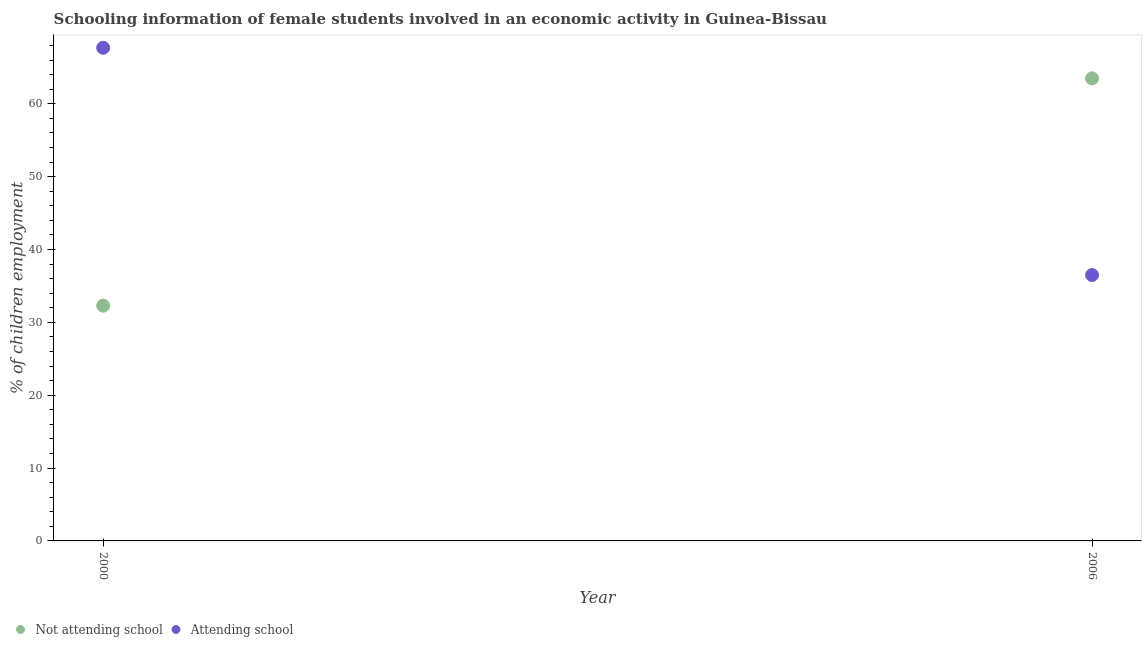What is the percentage of employed females who are not attending school in 2000?
Your answer should be very brief. 32.3. Across all years, what is the maximum percentage of employed females who are not attending school?
Your response must be concise. 63.5. Across all years, what is the minimum percentage of employed females who are attending school?
Offer a terse response. 36.5. In which year was the percentage of employed females who are not attending school minimum?
Keep it short and to the point. 2000. What is the total percentage of employed females who are attending school in the graph?
Make the answer very short. 104.2. What is the difference between the percentage of employed females who are not attending school in 2000 and that in 2006?
Make the answer very short. -31.2. What is the difference between the percentage of employed females who are attending school in 2006 and the percentage of employed females who are not attending school in 2000?
Keep it short and to the point. 4.2. What is the average percentage of employed females who are attending school per year?
Give a very brief answer. 52.1. In the year 2006, what is the difference between the percentage of employed females who are not attending school and percentage of employed females who are attending school?
Provide a short and direct response. 27. What is the ratio of the percentage of employed females who are attending school in 2000 to that in 2006?
Provide a short and direct response. 1.85. Is the percentage of employed females who are not attending school in 2000 less than that in 2006?
Your answer should be very brief. Yes. In how many years, is the percentage of employed females who are not attending school greater than the average percentage of employed females who are not attending school taken over all years?
Provide a short and direct response. 1. Does the percentage of employed females who are attending school monotonically increase over the years?
Ensure brevity in your answer.  No. Is the percentage of employed females who are attending school strictly greater than the percentage of employed females who are not attending school over the years?
Your answer should be very brief. No. What is the difference between two consecutive major ticks on the Y-axis?
Keep it short and to the point. 10. Does the graph contain any zero values?
Give a very brief answer. No. Does the graph contain grids?
Make the answer very short. No. How many legend labels are there?
Provide a succinct answer. 2. How are the legend labels stacked?
Your answer should be compact. Horizontal. What is the title of the graph?
Provide a short and direct response. Schooling information of female students involved in an economic activity in Guinea-Bissau. What is the label or title of the X-axis?
Your response must be concise. Year. What is the label or title of the Y-axis?
Keep it short and to the point. % of children employment. What is the % of children employment of Not attending school in 2000?
Offer a very short reply. 32.3. What is the % of children employment in Attending school in 2000?
Provide a succinct answer. 67.7. What is the % of children employment of Not attending school in 2006?
Your response must be concise. 63.5. What is the % of children employment of Attending school in 2006?
Offer a terse response. 36.5. Across all years, what is the maximum % of children employment in Not attending school?
Offer a terse response. 63.5. Across all years, what is the maximum % of children employment of Attending school?
Your answer should be compact. 67.7. Across all years, what is the minimum % of children employment in Not attending school?
Ensure brevity in your answer.  32.3. Across all years, what is the minimum % of children employment in Attending school?
Provide a short and direct response. 36.5. What is the total % of children employment in Not attending school in the graph?
Your answer should be compact. 95.8. What is the total % of children employment of Attending school in the graph?
Provide a succinct answer. 104.2. What is the difference between the % of children employment in Not attending school in 2000 and that in 2006?
Make the answer very short. -31.2. What is the difference between the % of children employment of Attending school in 2000 and that in 2006?
Keep it short and to the point. 31.2. What is the difference between the % of children employment of Not attending school in 2000 and the % of children employment of Attending school in 2006?
Provide a succinct answer. -4.2. What is the average % of children employment in Not attending school per year?
Your response must be concise. 47.9. What is the average % of children employment in Attending school per year?
Offer a terse response. 52.1. In the year 2000, what is the difference between the % of children employment of Not attending school and % of children employment of Attending school?
Offer a terse response. -35.4. What is the ratio of the % of children employment of Not attending school in 2000 to that in 2006?
Provide a succinct answer. 0.51. What is the ratio of the % of children employment of Attending school in 2000 to that in 2006?
Provide a short and direct response. 1.85. What is the difference between the highest and the second highest % of children employment of Not attending school?
Provide a short and direct response. 31.2. What is the difference between the highest and the second highest % of children employment in Attending school?
Your answer should be compact. 31.2. What is the difference between the highest and the lowest % of children employment in Not attending school?
Your answer should be very brief. 31.2. What is the difference between the highest and the lowest % of children employment of Attending school?
Provide a succinct answer. 31.2. 